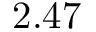Convert formula to latex. <formula><loc_0><loc_0><loc_500><loc_500>2 . 4 7</formula> 